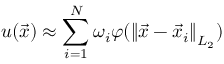<formula> <loc_0><loc_0><loc_500><loc_500>u ( \vec { x } ) \approx \sum _ { i = 1 } ^ { N } \omega _ { i } \varphi ( \left \| \vec { x } - \vec { x } _ { i } \right \| _ { L _ { 2 } } )</formula> 